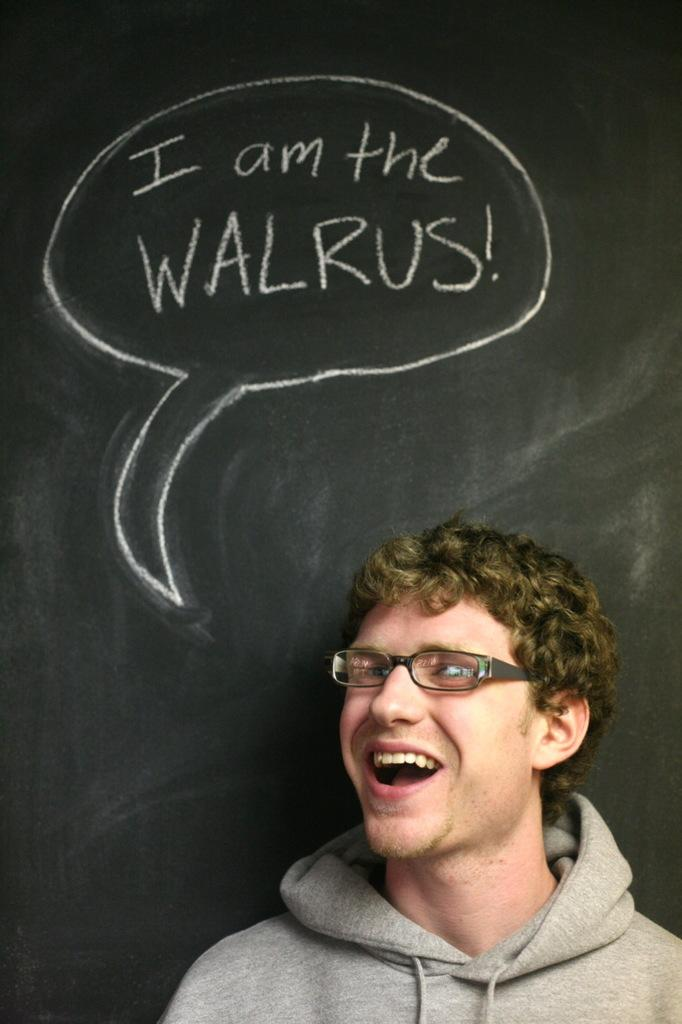What can be seen in the image? There is a person in the image. Can you describe the person's clothing? The person is wearing a gray color jacket. Are there any accessories visible on the person? Yes, the person is wearing spectacles. What is the person's facial expression? The person is smiling. What is behind the person in the image? The person is standing in front of a black color board. What is written on the board? There is text on the board. How does the person find comfort in the image? The image does not provide information about the person's comfort level. --- 